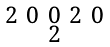<formula> <loc_0><loc_0><loc_500><loc_500>\begin{smallmatrix} 2 & 0 & 0 & 2 & 0 \\ & & 2 & & \end{smallmatrix}</formula> 